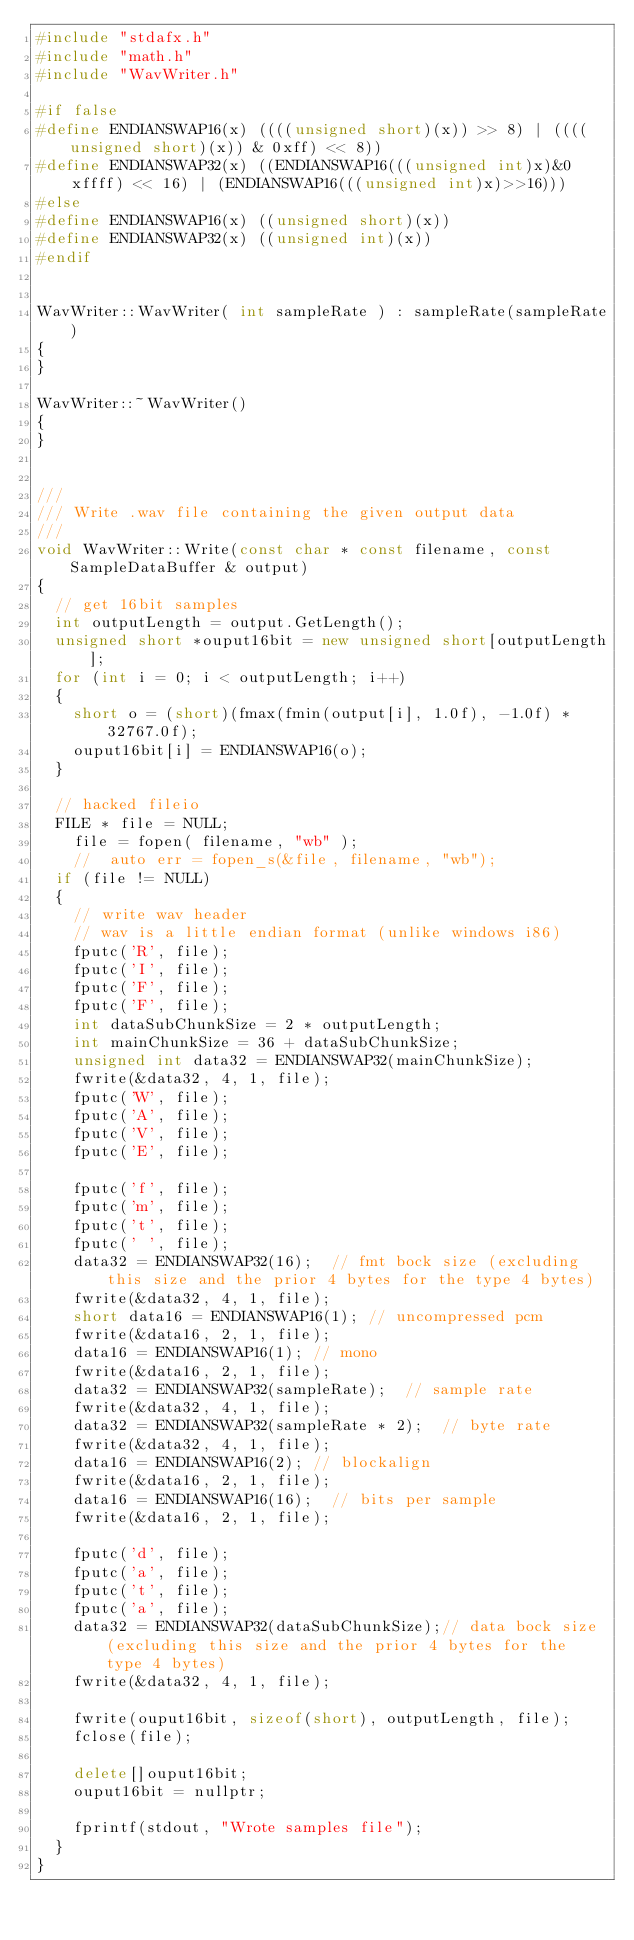Convert code to text. <code><loc_0><loc_0><loc_500><loc_500><_C++_>#include "stdafx.h"
#include "math.h"
#include "WavWriter.h"

#if false
#define ENDIANSWAP16(x) ((((unsigned short)(x)) >> 8) | ((((unsigned short)(x)) & 0xff) << 8))
#define ENDIANSWAP32(x) ((ENDIANSWAP16(((unsigned int)x)&0xffff) << 16) | (ENDIANSWAP16(((unsigned int)x)>>16)))
#else
#define ENDIANSWAP16(x) ((unsigned short)(x))
#define ENDIANSWAP32(x) ((unsigned int)(x))
#endif


WavWriter::WavWriter( int sampleRate ) : sampleRate(sampleRate)
{
}

WavWriter::~WavWriter()
{
}


///
/// Write .wav file containing the given output data
///
void WavWriter::Write(const char * const filename, const SampleDataBuffer & output)
{
	// get 16bit samples
	int outputLength = output.GetLength();
	unsigned short *ouput16bit = new unsigned short[outputLength];
	for (int i = 0; i < outputLength; i++)
	{
		short o = (short)(fmax(fmin(output[i], 1.0f), -1.0f) * 32767.0f);
		ouput16bit[i] = ENDIANSWAP16(o);
	}

	// hacked fileio
	FILE * file = NULL;
    file = fopen( filename, "wb" );
    //	auto err = fopen_s(&file, filename, "wb");
	if (file != NULL)
	{
		// write wav header
		// wav is a little endian format (unlike windows i86)
		fputc('R', file);
		fputc('I', file);
		fputc('F', file);
		fputc('F', file);
		int dataSubChunkSize = 2 * outputLength;
		int mainChunkSize = 36 + dataSubChunkSize;
		unsigned int data32 = ENDIANSWAP32(mainChunkSize);
		fwrite(&data32, 4, 1, file);
		fputc('W', file);
		fputc('A', file);
		fputc('V', file);
		fputc('E', file);

		fputc('f', file);
		fputc('m', file);
		fputc('t', file);
		fputc(' ', file);
		data32 = ENDIANSWAP32(16);	// fmt bock size (excluding this size and the prior 4 bytes for the type 4 bytes)
		fwrite(&data32, 4, 1, file);
		short data16 = ENDIANSWAP16(1);	// uncompressed pcm
		fwrite(&data16, 2, 1, file);
		data16 = ENDIANSWAP16(1);	// mono
		fwrite(&data16, 2, 1, file);
		data32 = ENDIANSWAP32(sampleRate);	// sample rate
		fwrite(&data32, 4, 1, file);
		data32 = ENDIANSWAP32(sampleRate * 2);	// byte rate
		fwrite(&data32, 4, 1, file);
		data16 = ENDIANSWAP16(2);	// blockalign
		fwrite(&data16, 2, 1, file);
		data16 = ENDIANSWAP16(16);	// bits per sample
		fwrite(&data16, 2, 1, file);

		fputc('d', file);
		fputc('a', file);
		fputc('t', file);
		fputc('a', file);
		data32 = ENDIANSWAP32(dataSubChunkSize);// data bock size (excluding this size and the prior 4 bytes for the type 4 bytes)
		fwrite(&data32, 4, 1, file);

		fwrite(ouput16bit, sizeof(short), outputLength, file);
		fclose(file);

		delete[]ouput16bit;
		ouput16bit = nullptr;

		fprintf(stdout, "Wrote samples file");
	}
}
</code> 